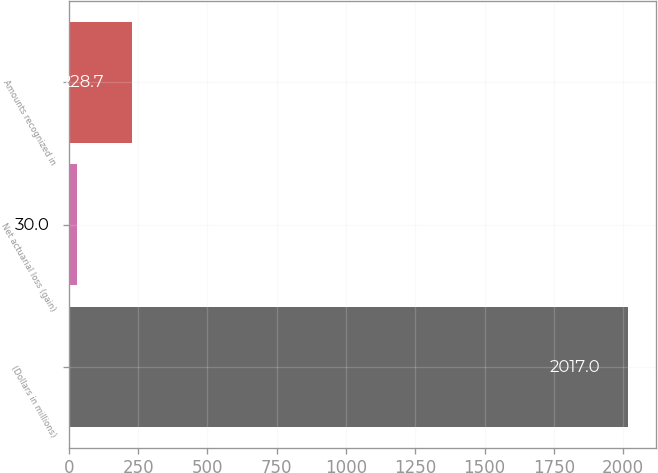<chart> <loc_0><loc_0><loc_500><loc_500><bar_chart><fcel>(Dollars in millions)<fcel>Net actuarial loss (gain)<fcel>Amounts recognized in<nl><fcel>2017<fcel>30<fcel>228.7<nl></chart> 